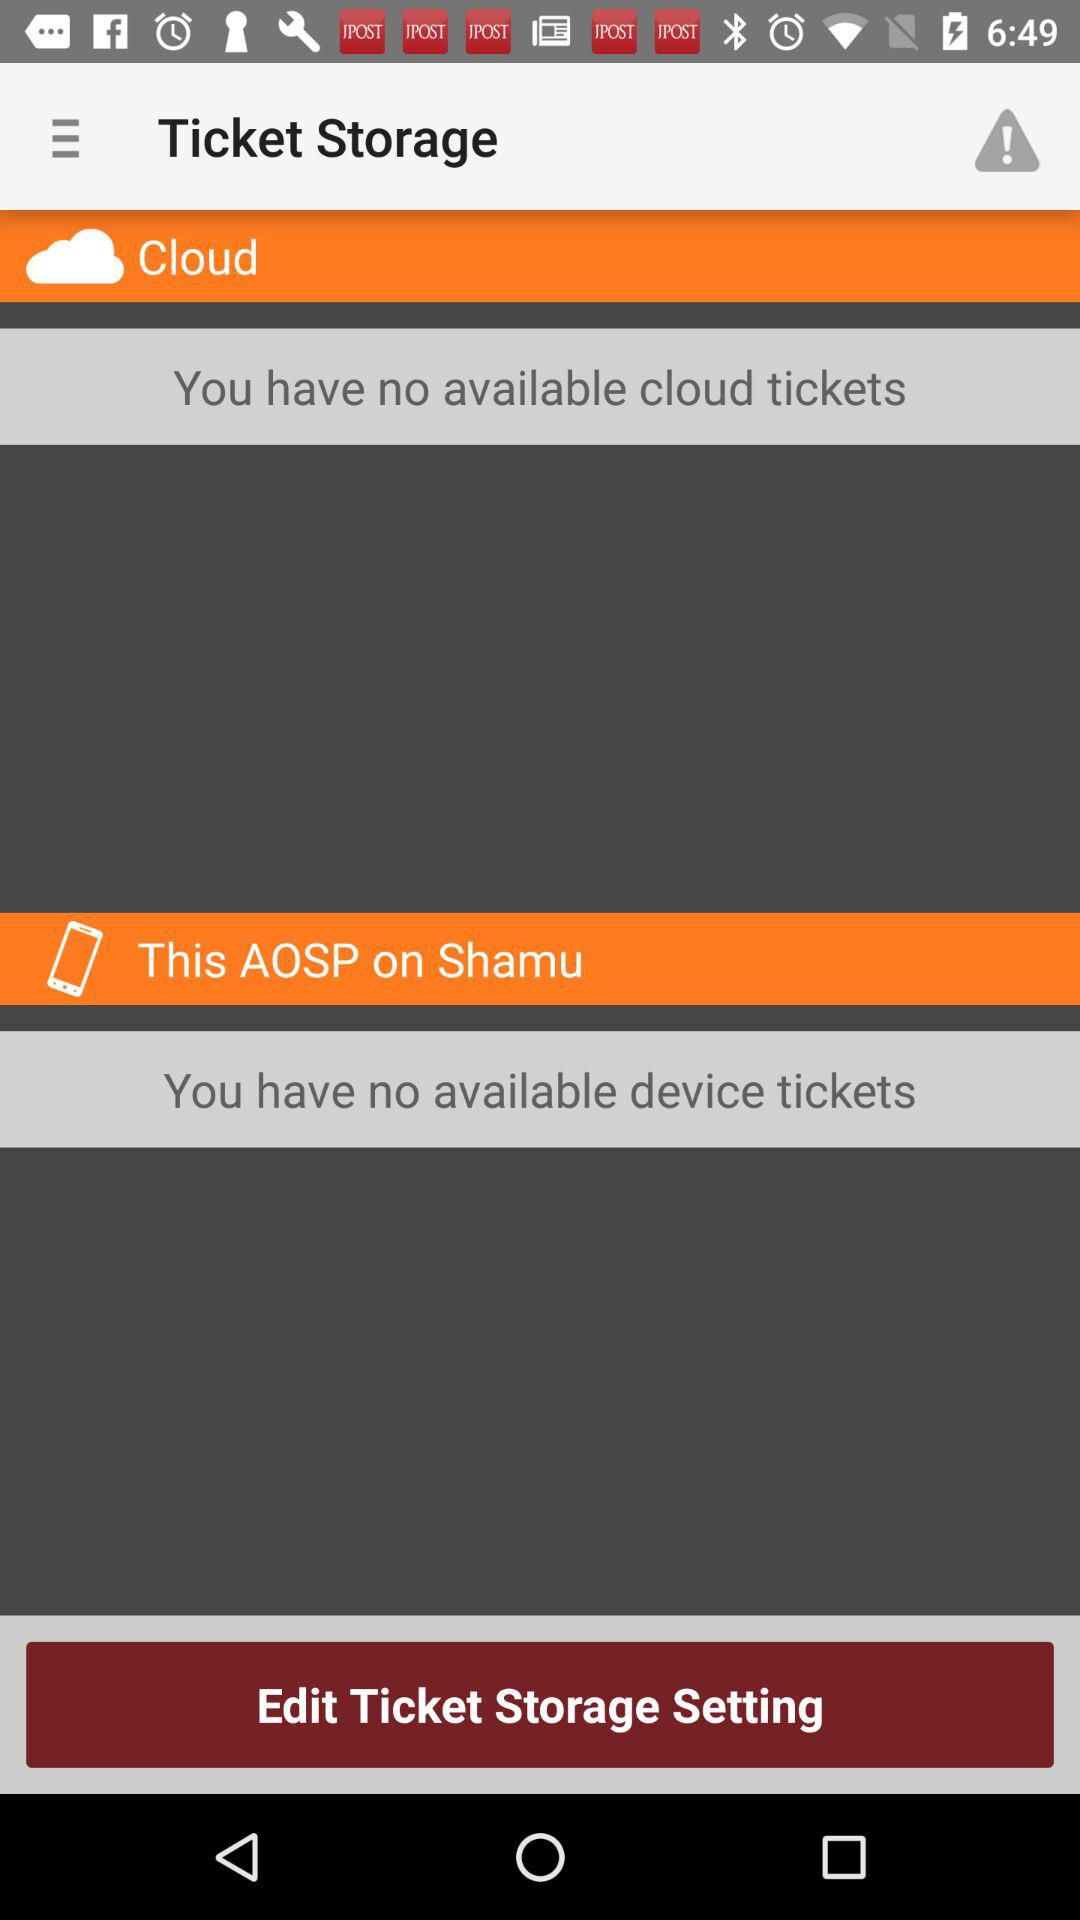How many tickets are available on the cloud?
Answer the question using a single word or phrase. 0 